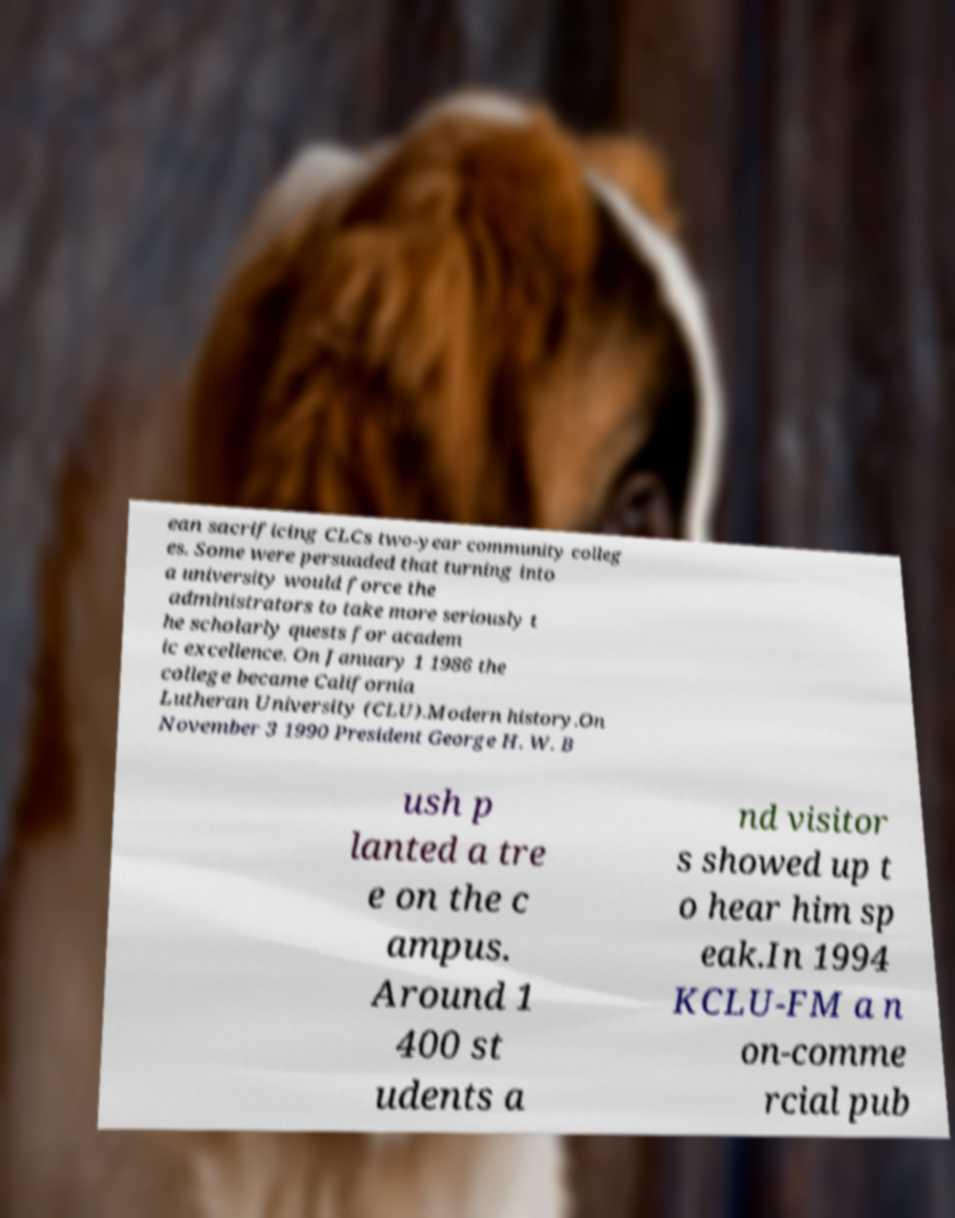For documentation purposes, I need the text within this image transcribed. Could you provide that? ean sacrificing CLCs two-year community colleg es. Some were persuaded that turning into a university would force the administrators to take more seriously t he scholarly quests for academ ic excellence. On January 1 1986 the college became California Lutheran University (CLU).Modern history.On November 3 1990 President George H. W. B ush p lanted a tre e on the c ampus. Around 1 400 st udents a nd visitor s showed up t o hear him sp eak.In 1994 KCLU-FM a n on-comme rcial pub 